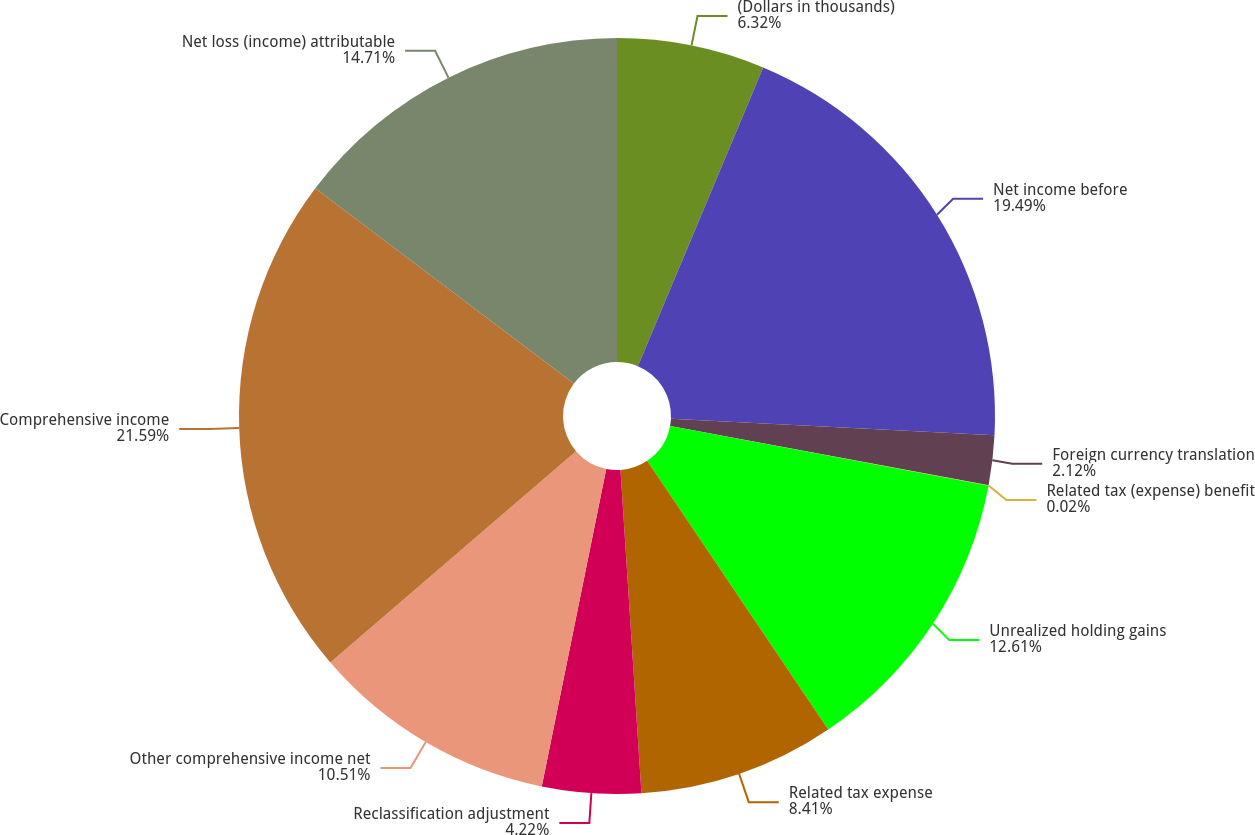Convert chart. <chart><loc_0><loc_0><loc_500><loc_500><pie_chart><fcel>(Dollars in thousands)<fcel>Net income before<fcel>Foreign currency translation<fcel>Related tax (expense) benefit<fcel>Unrealized holding gains<fcel>Related tax expense<fcel>Reclassification adjustment<fcel>Other comprehensive income net<fcel>Comprehensive income<fcel>Net loss (income) attributable<nl><fcel>6.32%<fcel>19.49%<fcel>2.12%<fcel>0.02%<fcel>12.61%<fcel>8.41%<fcel>4.22%<fcel>10.51%<fcel>21.59%<fcel>14.71%<nl></chart> 